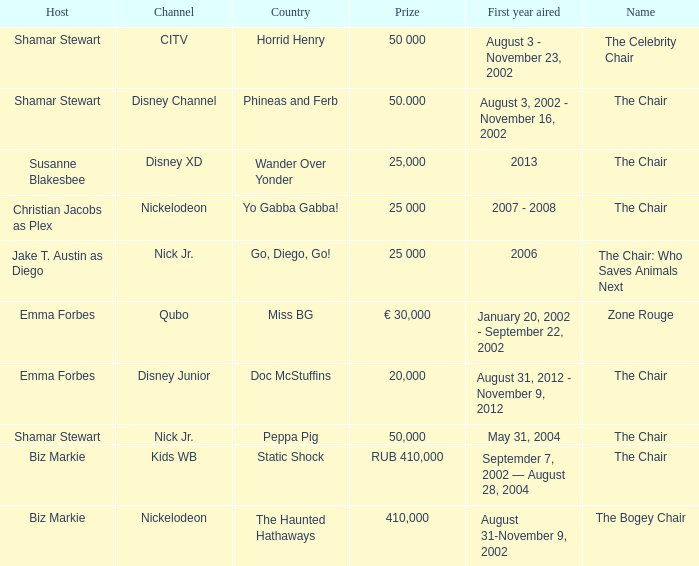What was the host of Horrid Henry? Shamar Stewart. 